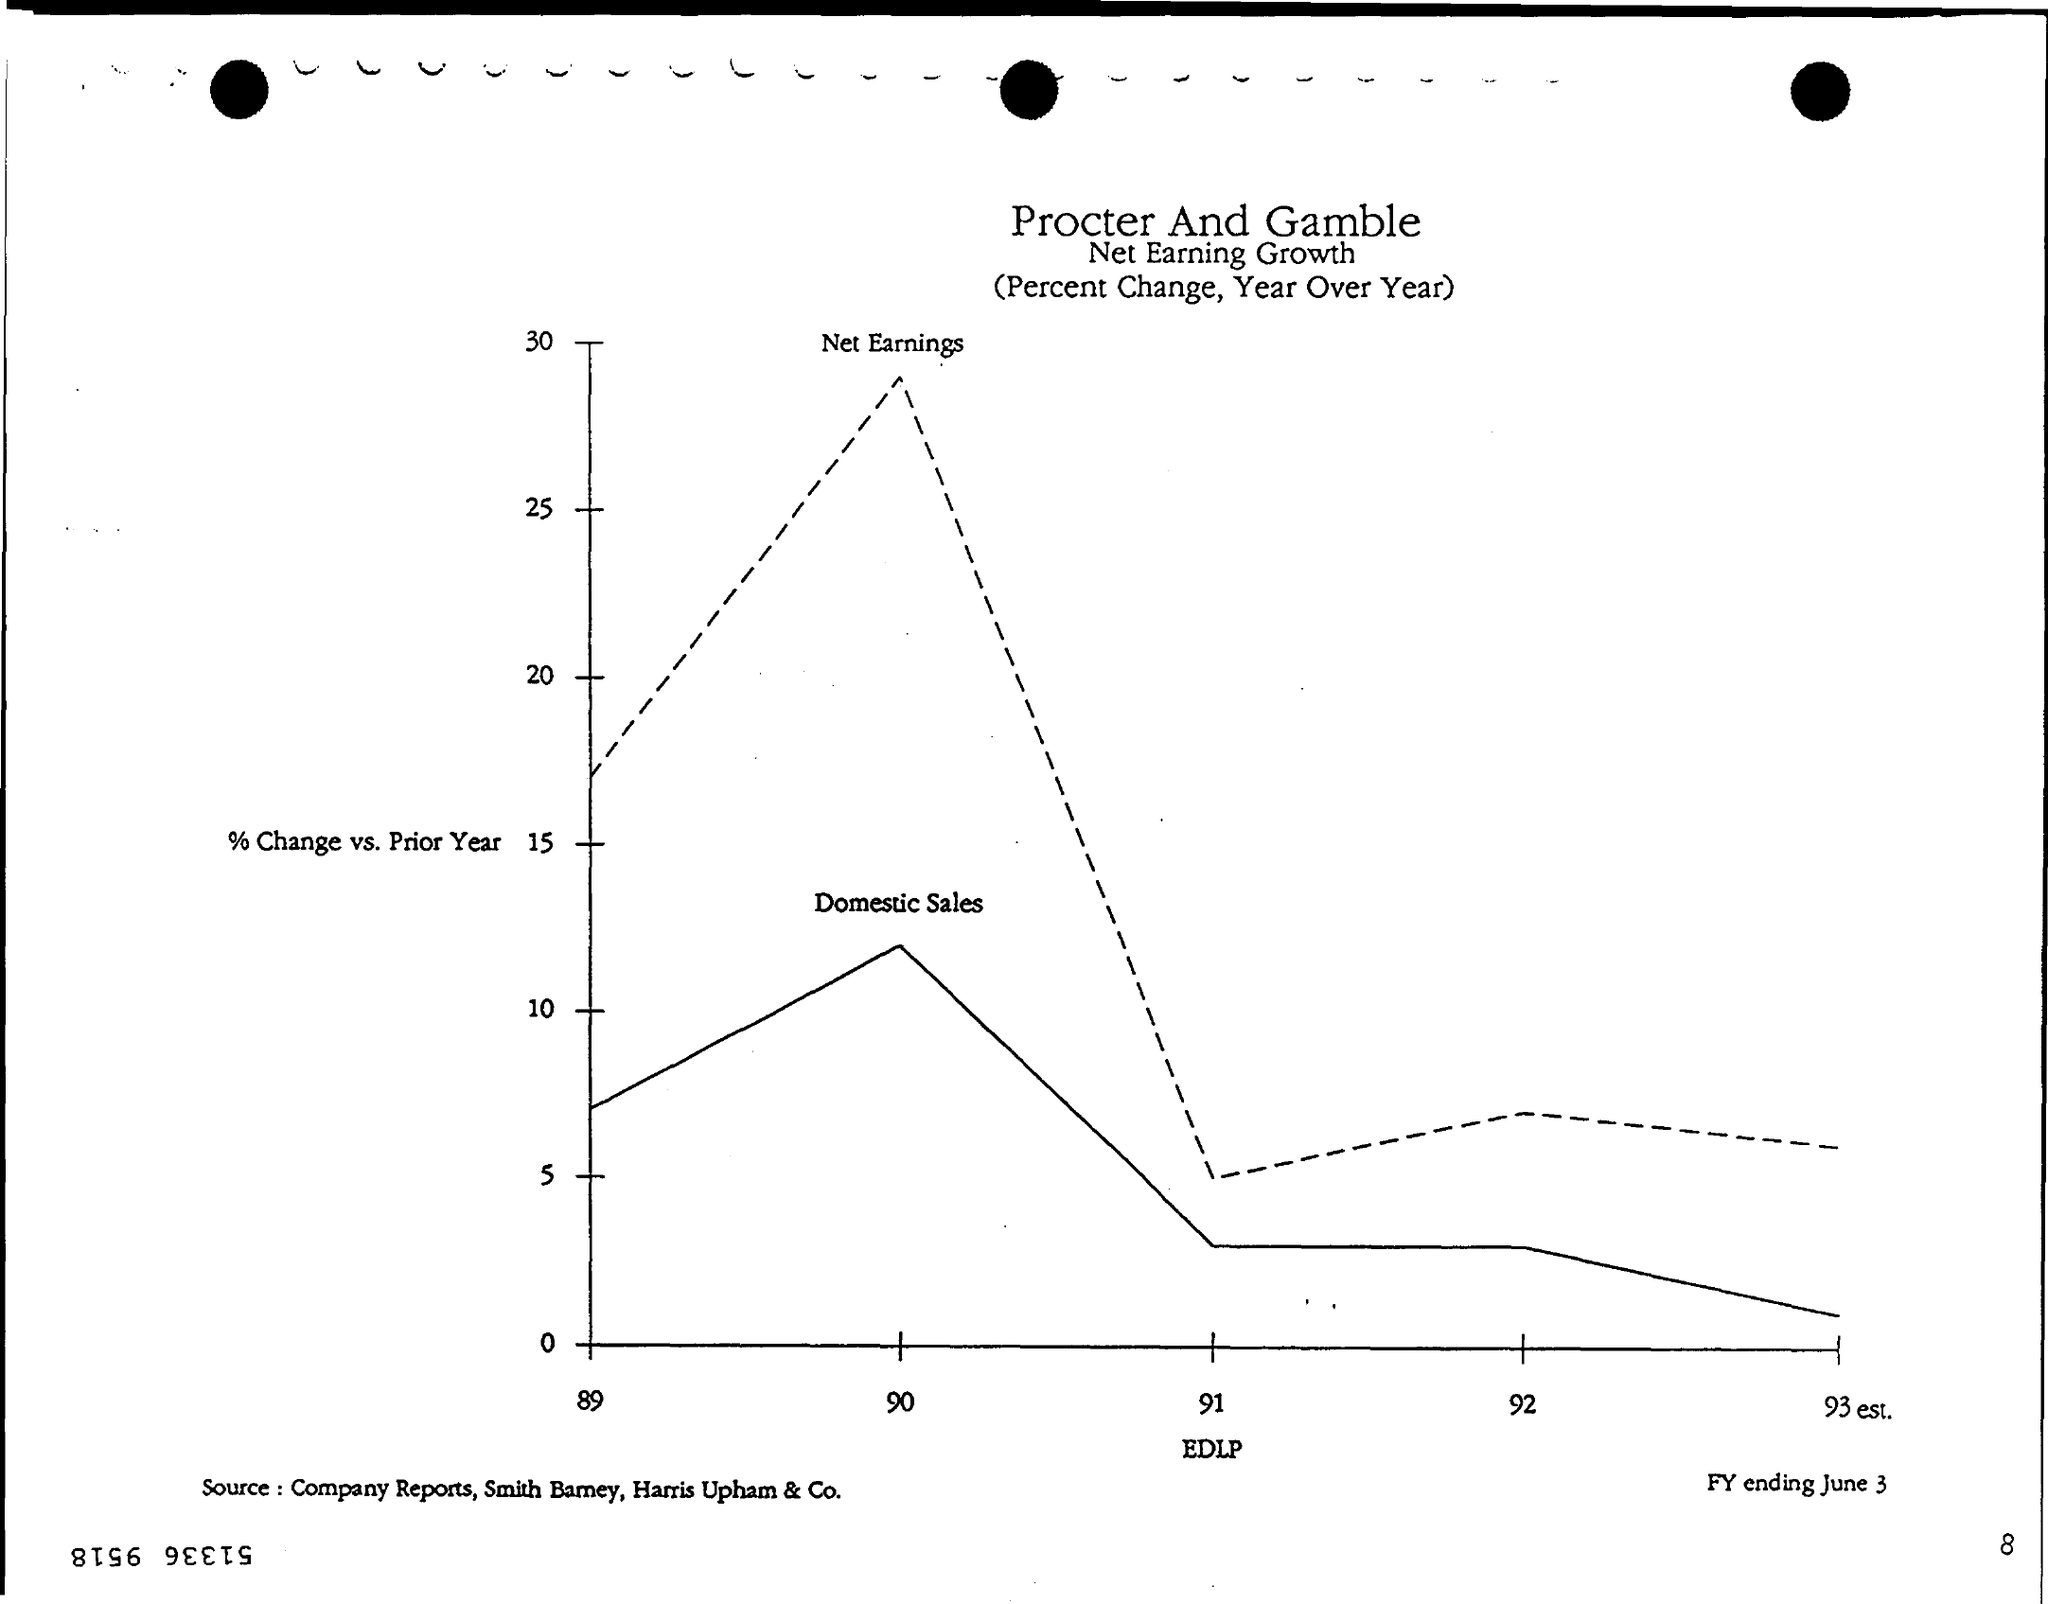Point out several critical features in this image. The page number is 8. The first title in the document is "Procter and Gamble. The value of EDLP is plotted on the x-axis in the graph. The y-axis in the graph shows the percentage change in sales from the previous year. 